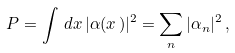Convert formula to latex. <formula><loc_0><loc_0><loc_500><loc_500>P = \int \, d { x } \, | \alpha ( { x } \, ) | ^ { 2 } = \sum _ { n } | \alpha _ { n } | ^ { 2 } \, ,</formula> 